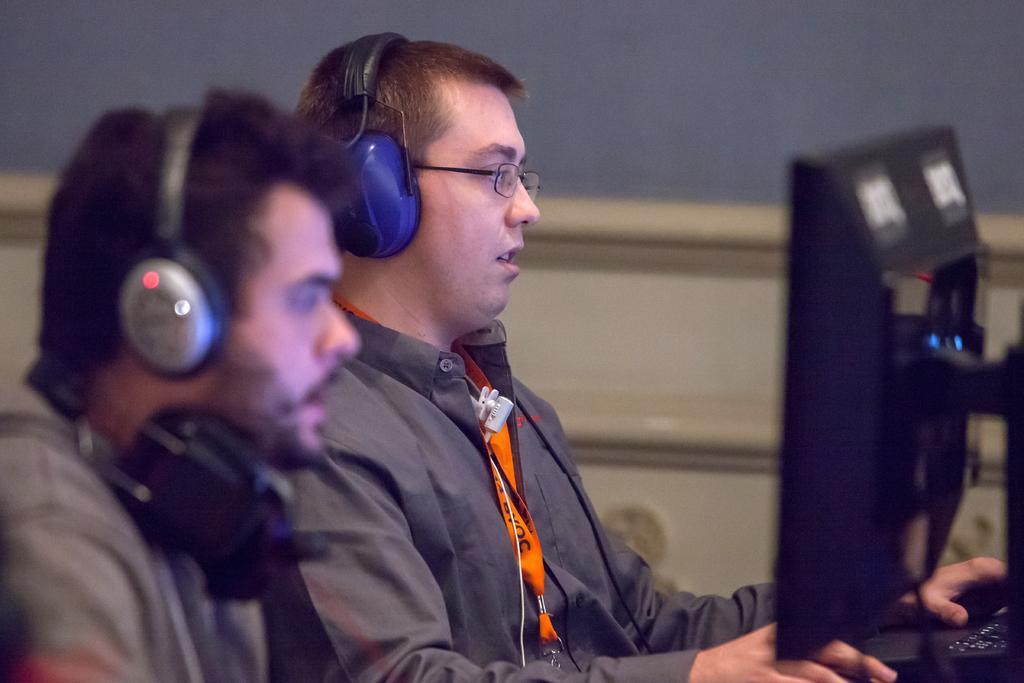Can you describe this image briefly? There are two persons sitting and wearing headphones. On the right side there is computer and keyboard. 